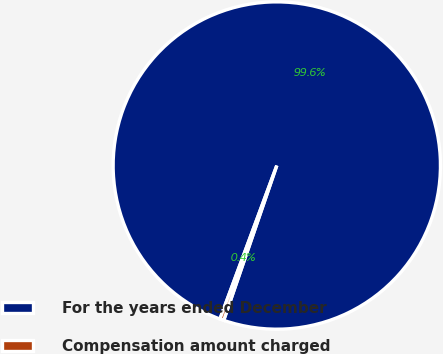Convert chart to OTSL. <chart><loc_0><loc_0><loc_500><loc_500><pie_chart><fcel>For the years ended December<fcel>Compensation amount charged<nl><fcel>99.61%<fcel>0.39%<nl></chart> 